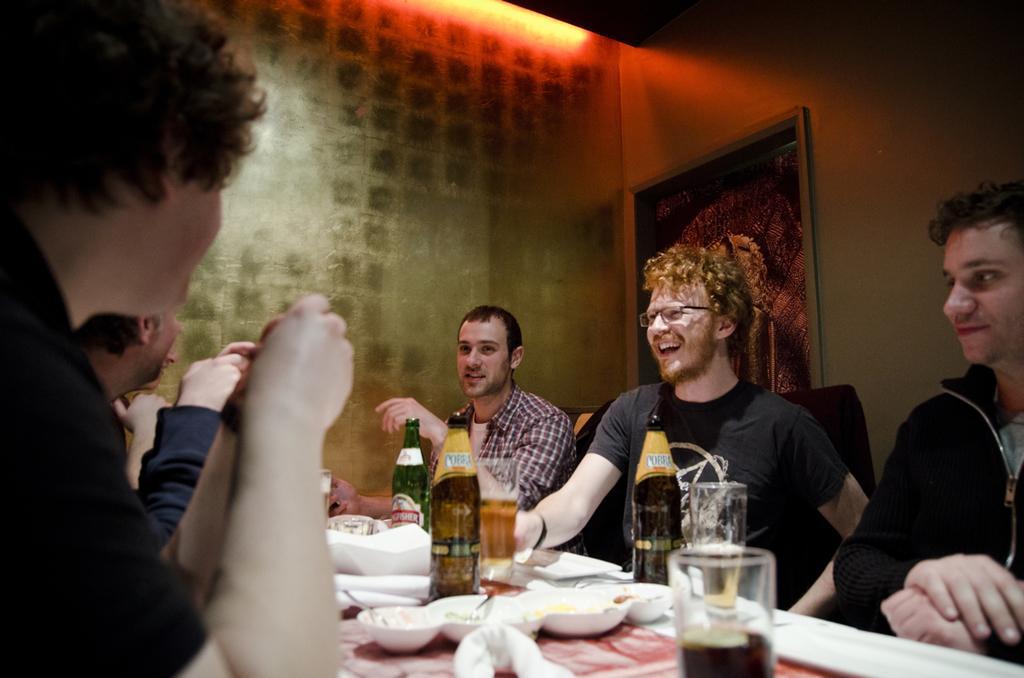In one or two sentences, can you explain what this image depicts? In this picture there are many people sitting on the table where there are glass bottles ,plates on top of it. In the background we observe a painting and there is a red light. 